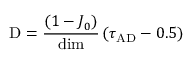<formula> <loc_0><loc_0><loc_500><loc_500>D = \frac { ( 1 - J _ { 0 } ) } { d i m } \left ( \tau _ { A D } - 0 . 5 \right )</formula> 